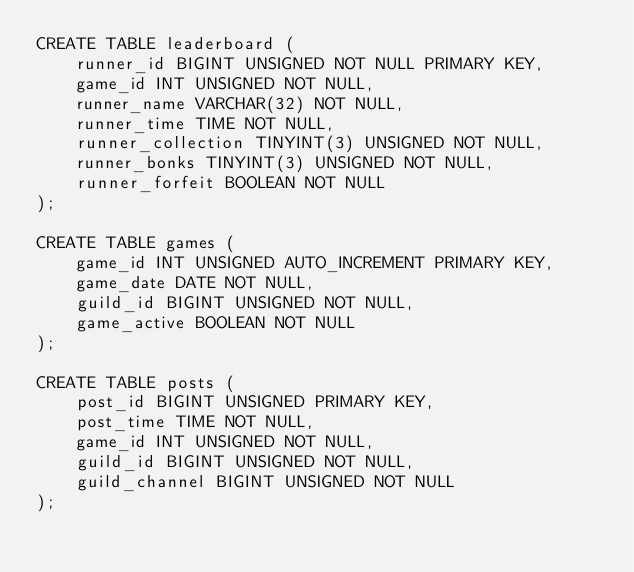<code> <loc_0><loc_0><loc_500><loc_500><_SQL_>CREATE TABLE leaderboard (
    runner_id BIGINT UNSIGNED NOT NULL PRIMARY KEY,
    game_id INT UNSIGNED NOT NULL,
    runner_name VARCHAR(32) NOT NULL,
    runner_time TIME NOT NULL,
    runner_collection TINYINT(3) UNSIGNED NOT NULL,
    runner_bonks TINYINT(3) UNSIGNED NOT NULL,
    runner_forfeit BOOLEAN NOT NULL
);

CREATE TABLE games (
    game_id INT UNSIGNED AUTO_INCREMENT PRIMARY KEY,
    game_date DATE NOT NULL,
    guild_id BIGINT UNSIGNED NOT NULL,
    game_active BOOLEAN NOT NULL
);

CREATE TABLE posts (
    post_id BIGINT UNSIGNED PRIMARY KEY,
    post_time TIME NOT NULL,
    game_id INT UNSIGNED NOT NULL,
    guild_id BIGINT UNSIGNED NOT NULL,
    guild_channel BIGINT UNSIGNED NOT NULL
);
</code> 